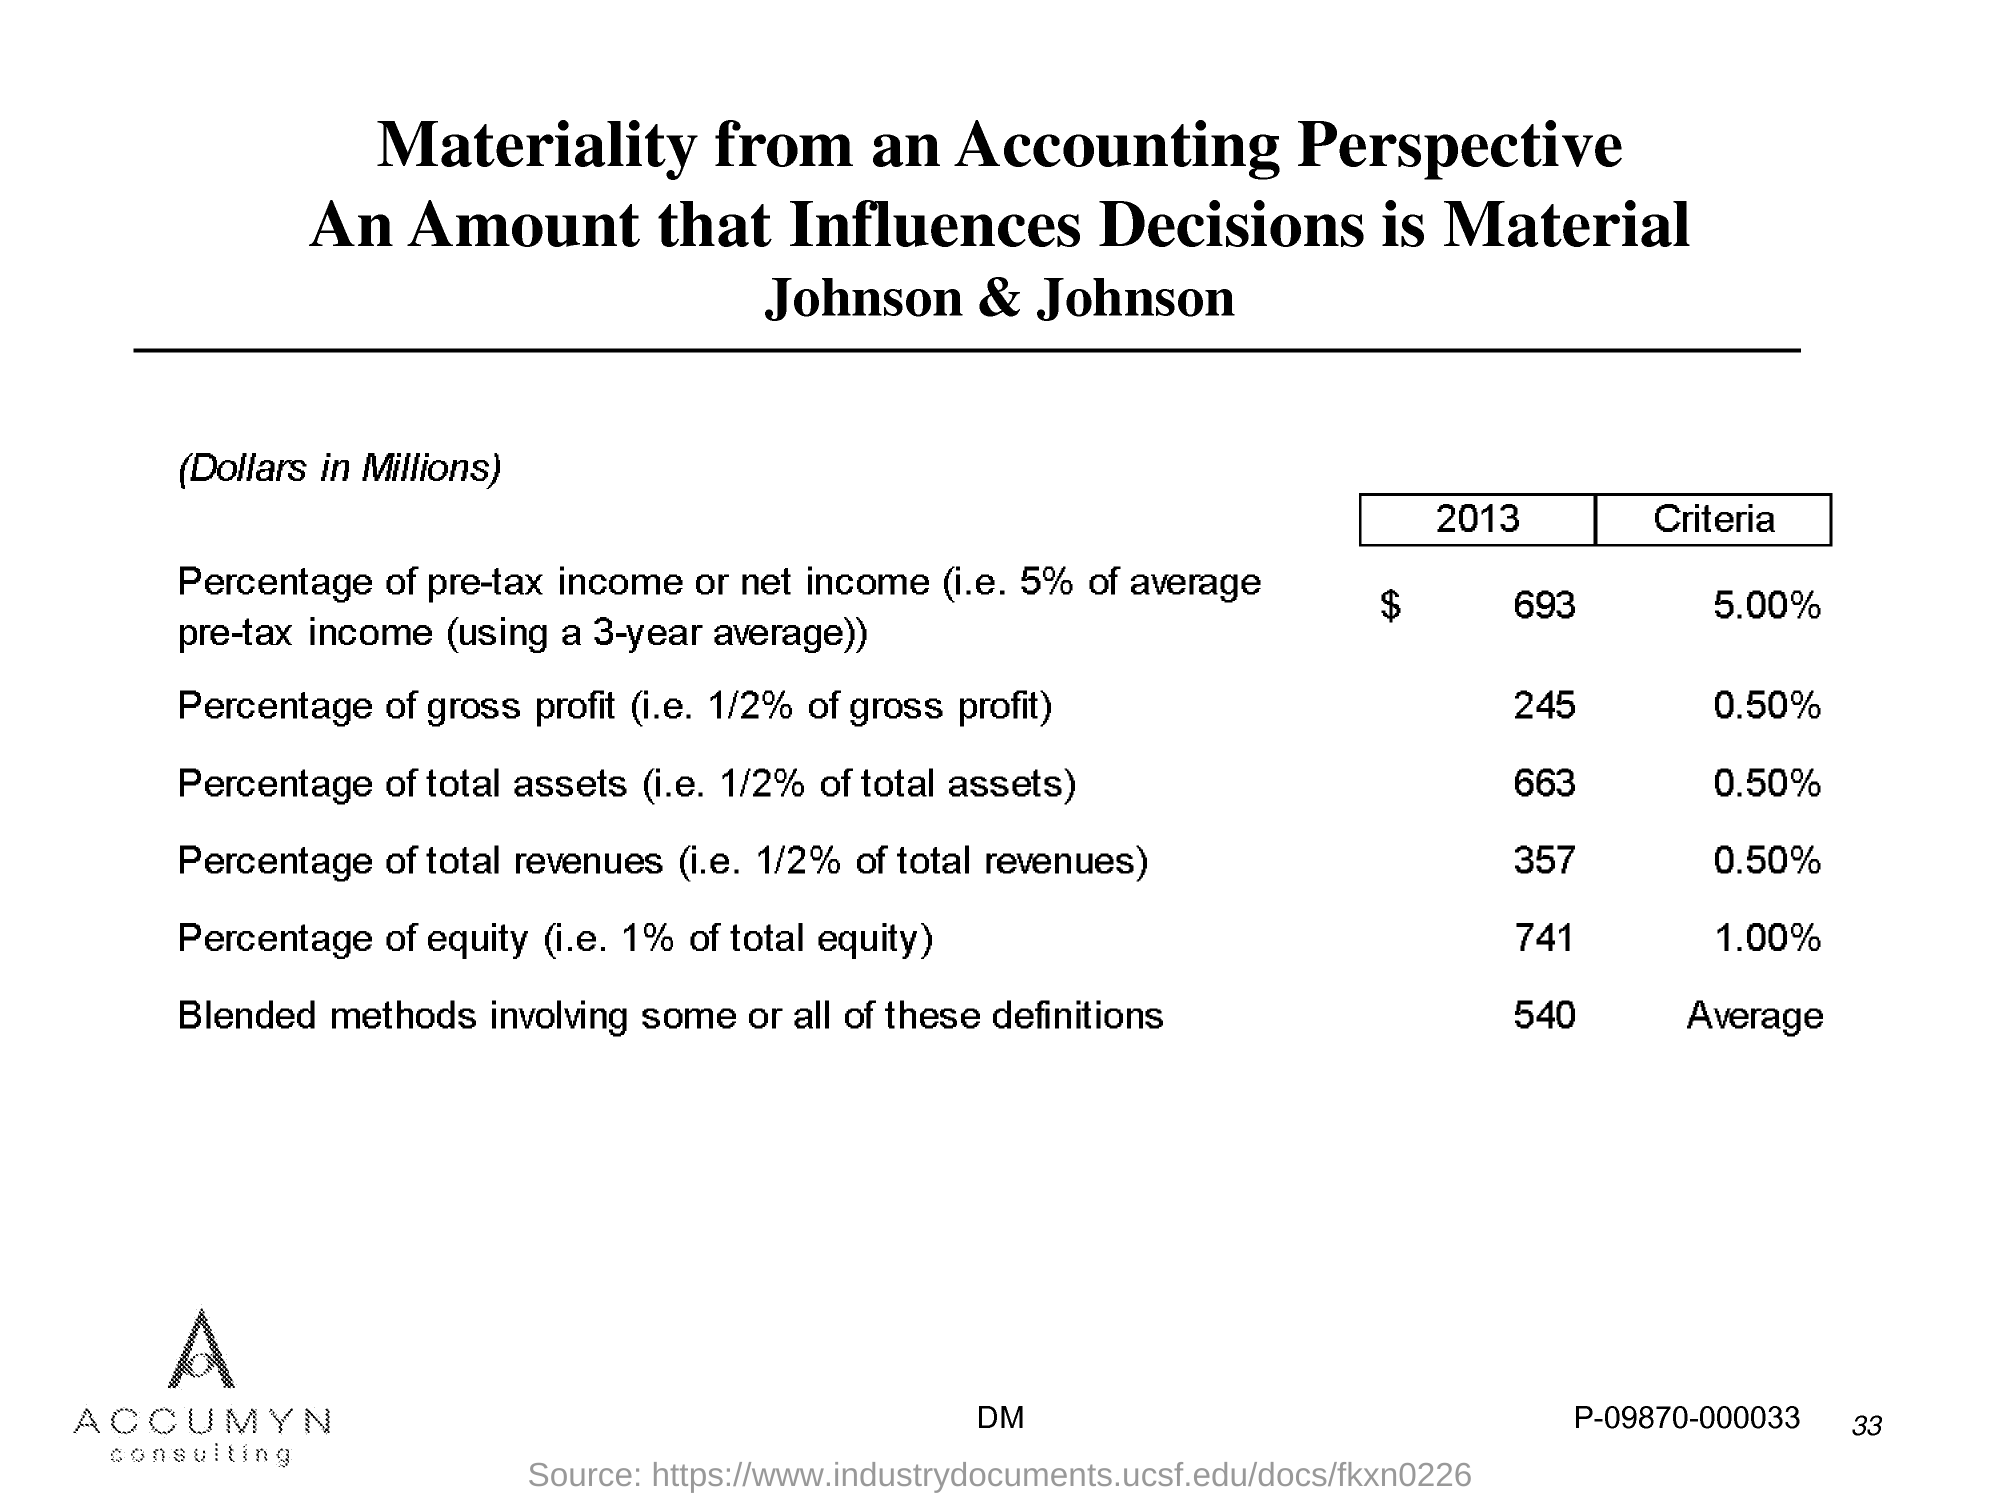What is the Page Number?
Keep it short and to the point. 33. 